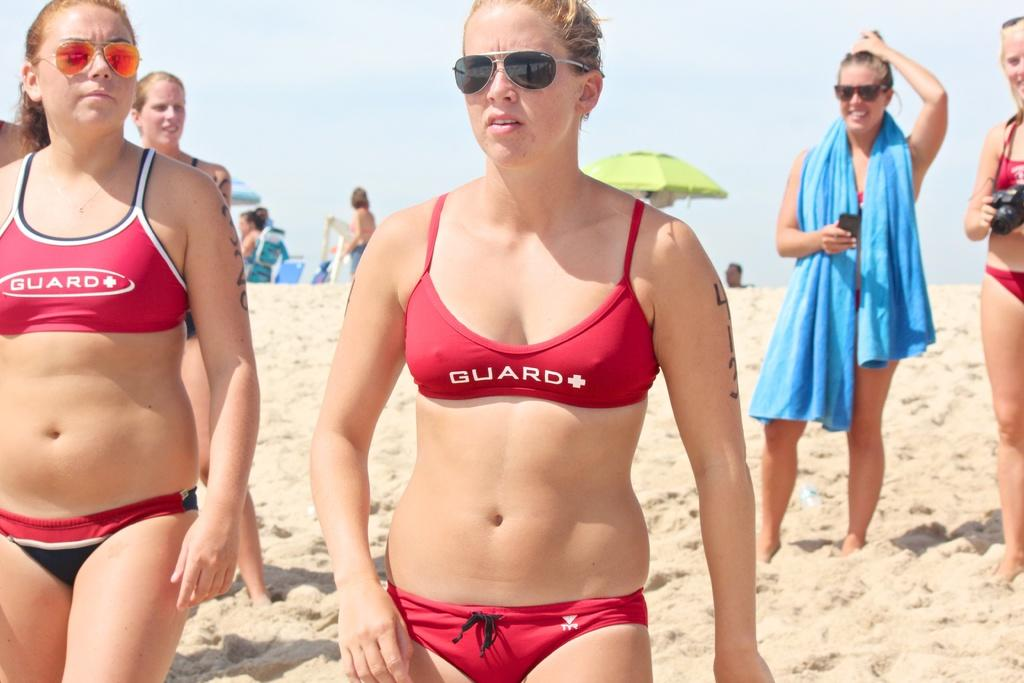<image>
Offer a succinct explanation of the picture presented. A woman in a red suit that says guard on the front is on the beach. 